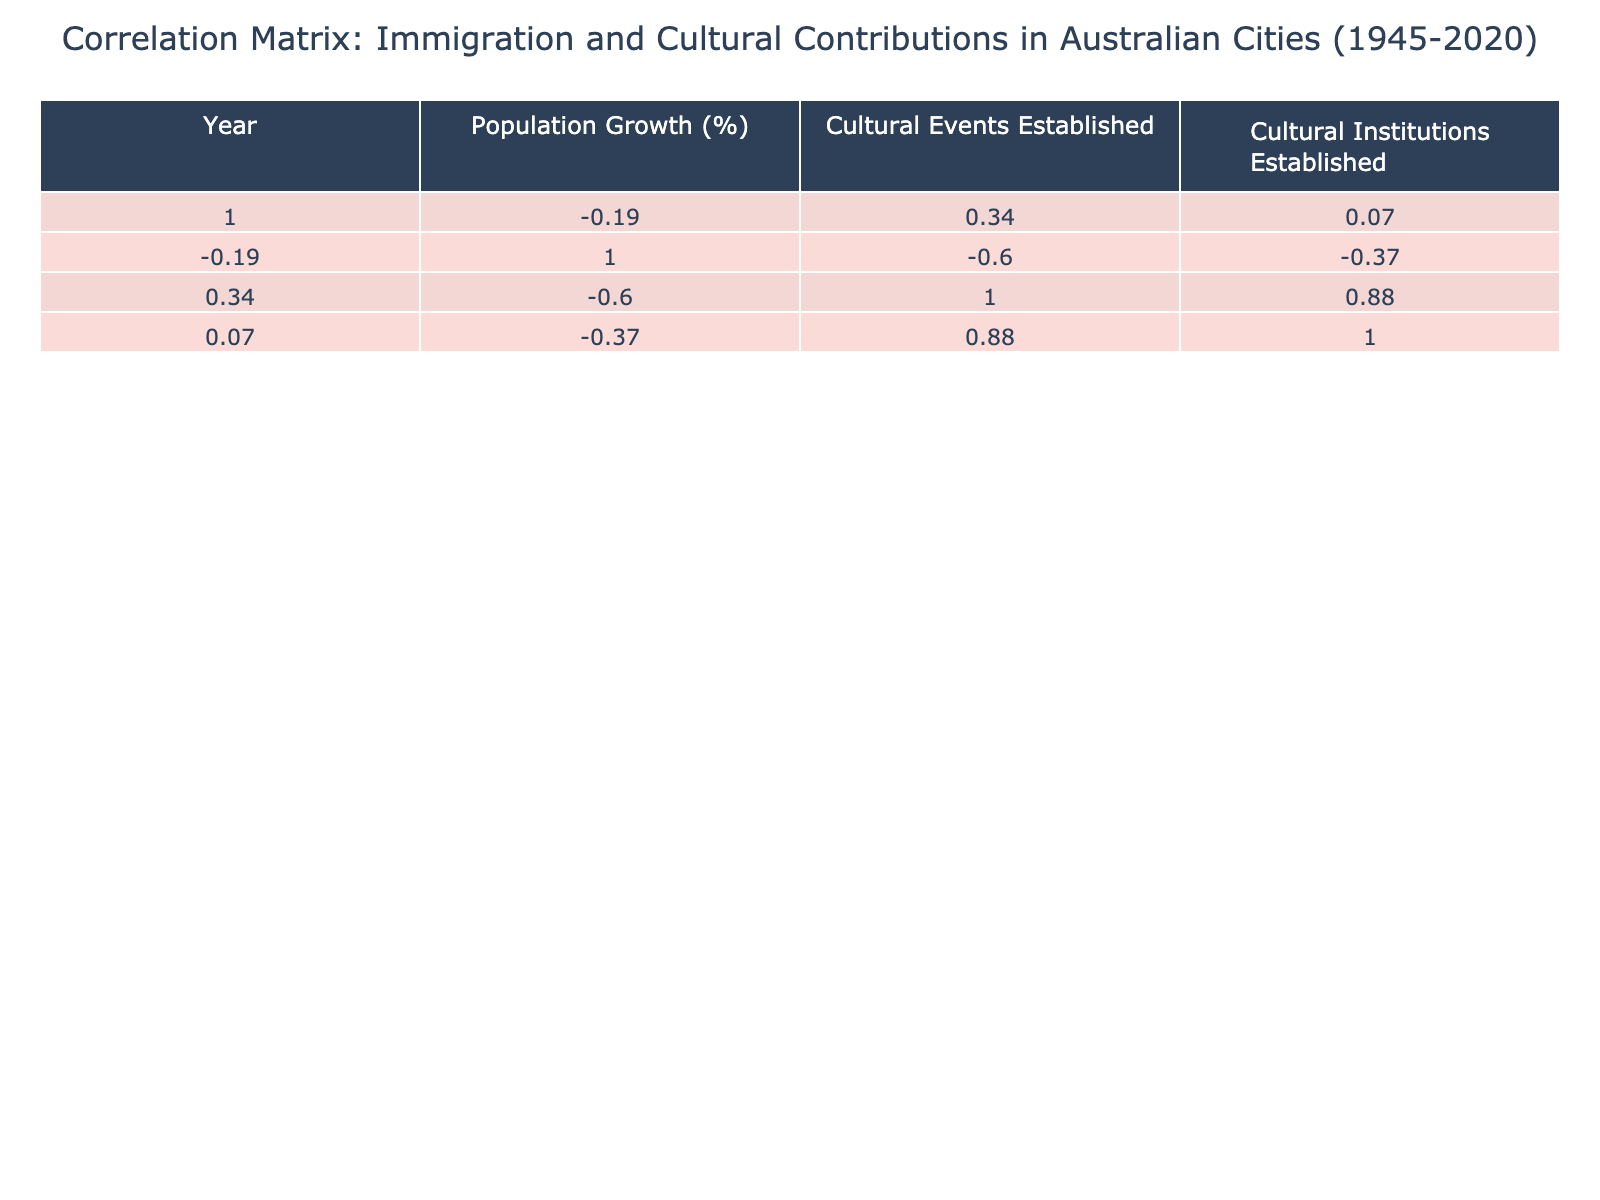What is the highest percentage of population growth recorded in the table? The population growth percentages listed are 22, 30, 25, 35, 28, 20, 15, 18, and 32. The highest value among these is 35, which corresponds to Perth in the year 1975.
Answer: 35 Which city had the most cultural events established during its immigration wave? The cultural events established are 15, 20, 10, 18, 12, 25, 30, 22, and 14. The highest number is 30, which belongs to Melbourne in the year 2000.
Answer: Melbourne Is it true that all cities recorded a population growth of at least 15%? The population growth figures are 22, 30, 25, 35, 28, 20, 15, 18, and 32. The lowest figure is 15, which indicates that all cities have achieved at least this percentage. Therefore, the statement is true.
Answer: Yes What is the average number of cultural institutions established across the cities? The number of cultural institutions established are 5, 7, 3, 6, 4, 9, 8, 5, and 4. Summing these gives: 5 + 7 + 3 + 6 + 4 + 9 + 8 + 5 + 4 = 51. Dividing by the number of cities (9) yields an average of 51/9, which is approximately 5.67.
Answer: 5.67 Which immigration wave corresponds to the year with the least number of cultural institutions established? The cultural institutions established are 5, 7, 3, 6, 4, 9, 8, 5, and 4. The minimum is 3, recorded for Brisbane in 1960 during the Italian Migration.
Answer: Italian Migration in 1960 How many notable cultural contributors are identified in the table? The table includes a list of notable cultural contributors for each city, totaling 9 distinct individuals.
Answer: 9 What is the difference in the number of cultural events established between Sydney in 1990 and Melbourne in 2000? Sydney in 1990 had 25 cultural events established, while Melbourne in 2000 had 30. The difference is 30 - 25 = 5.
Answer: 5 Which city experienced an immigration wave that resulted in a population growth of 18%? The only city with an 18% population growth is Brisbane in the year 2010, during the South American Immigration wave.
Answer: Brisbane in 2010 What is the city with the lowest number of cultural institutions established? The cultural institutions values are 5, 7, 3, 6, 4, 9, 8, 5, and 4. The lowest is 3, which corresponds to Brisbane in 1960.
Answer: Brisbane in 1960 